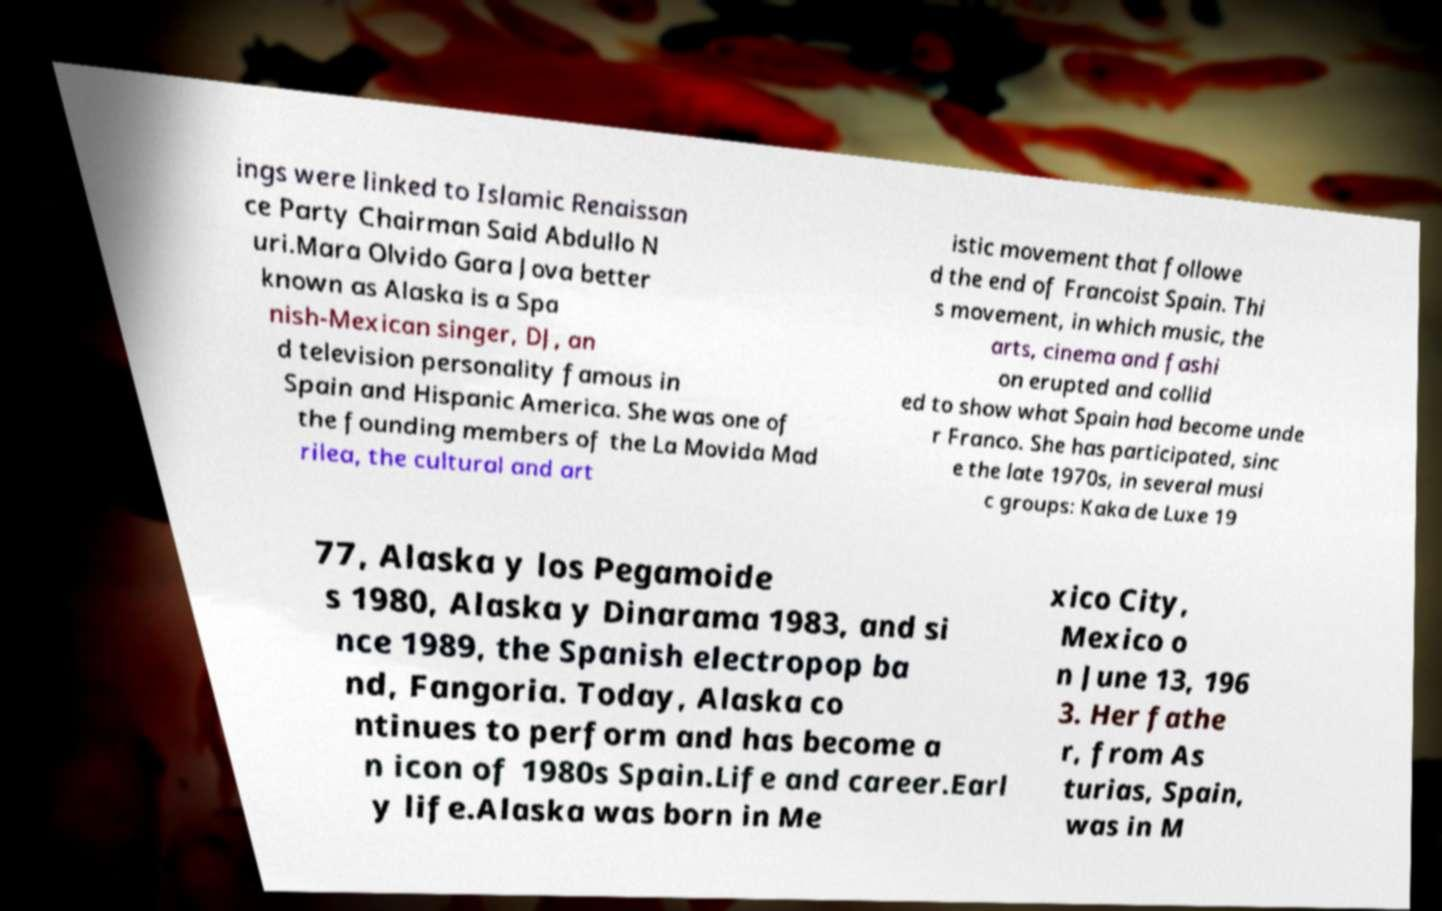Could you assist in decoding the text presented in this image and type it out clearly? ings were linked to Islamic Renaissan ce Party Chairman Said Abdullo N uri.Mara Olvido Gara Jova better known as Alaska is a Spa nish-Mexican singer, DJ, an d television personality famous in Spain and Hispanic America. She was one of the founding members of the La Movida Mad rilea, the cultural and art istic movement that followe d the end of Francoist Spain. Thi s movement, in which music, the arts, cinema and fashi on erupted and collid ed to show what Spain had become unde r Franco. She has participated, sinc e the late 1970s, in several musi c groups: Kaka de Luxe 19 77, Alaska y los Pegamoide s 1980, Alaska y Dinarama 1983, and si nce 1989, the Spanish electropop ba nd, Fangoria. Today, Alaska co ntinues to perform and has become a n icon of 1980s Spain.Life and career.Earl y life.Alaska was born in Me xico City, Mexico o n June 13, 196 3. Her fathe r, from As turias, Spain, was in M 